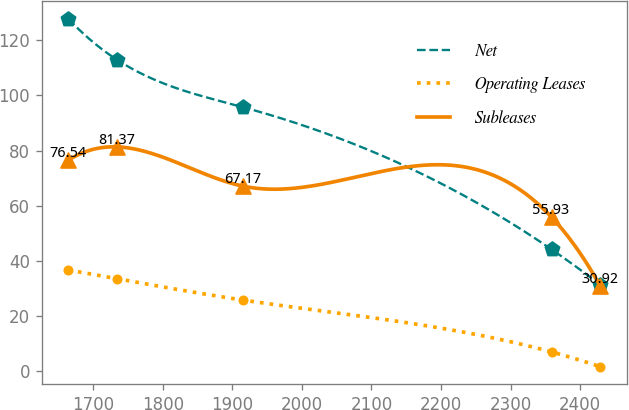Convert chart to OTSL. <chart><loc_0><loc_0><loc_500><loc_500><line_chart><ecel><fcel>Net<fcel>Operating Leases<fcel>Subleases<nl><fcel>1664.29<fcel>127.77<fcel>36.77<fcel>76.54<nl><fcel>1734.42<fcel>112.91<fcel>33.58<fcel>81.37<nl><fcel>1915.04<fcel>95.78<fcel>25.89<fcel>67.17<nl><fcel>2358.95<fcel>44.24<fcel>7.1<fcel>55.93<nl><fcel>2429.08<fcel>31.4<fcel>1.73<fcel>30.92<nl></chart> 